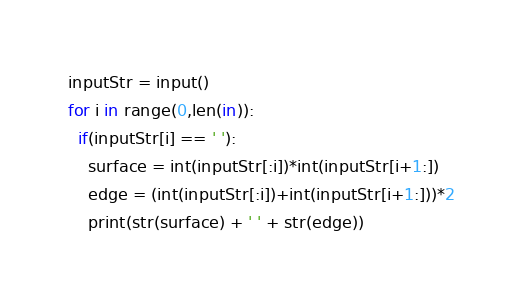Convert code to text. <code><loc_0><loc_0><loc_500><loc_500><_Python_>inputStr = input()
for i in range(0,len(in)):
  if(inputStr[i] == ' '):
    surface = int(inputStr[:i])*int(inputStr[i+1:])
    edge = (int(inputStr[:i])+int(inputStr[i+1:]))*2
    print(str(surface) + ' ' + str(edge))</code> 